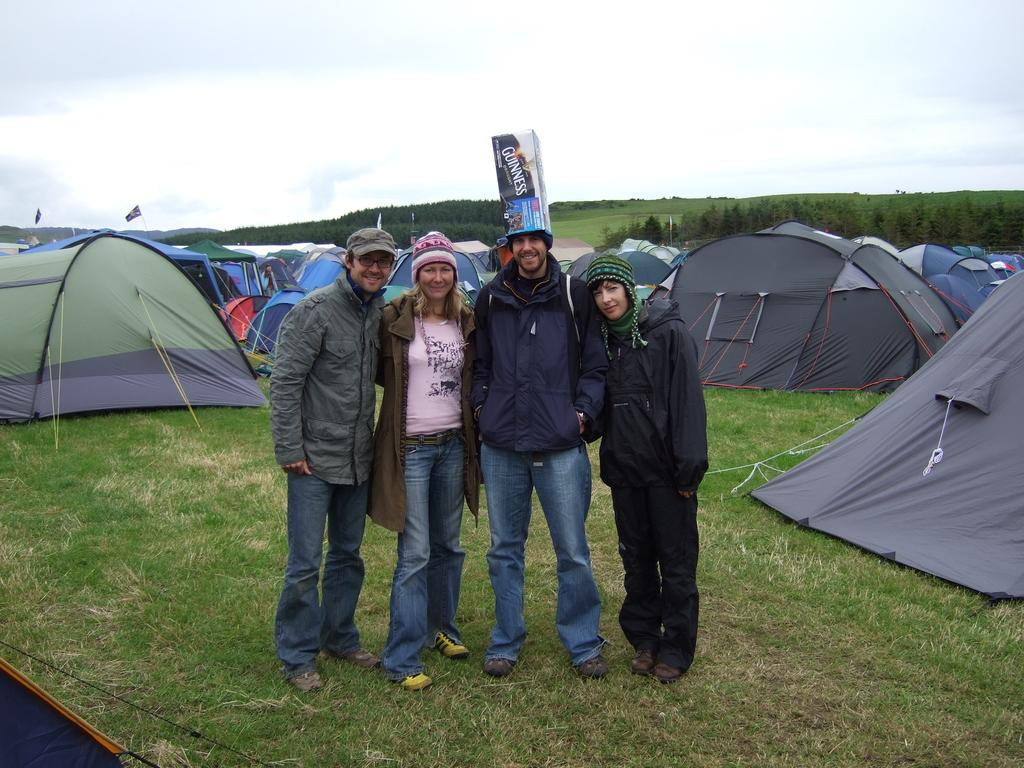How many people are in the image? There are four persons in the image. What are the persons doing in the image? The persons are standing on the grass and watching and smiling. What can be seen in the background of the image? There are tents, trees, and the sky visible in the background of the image. What type of knife can be seen in the image? There is no knife present in the image. Can you hear thunder in the image? The image is silent, and there is no indication of thunder or any sound. 